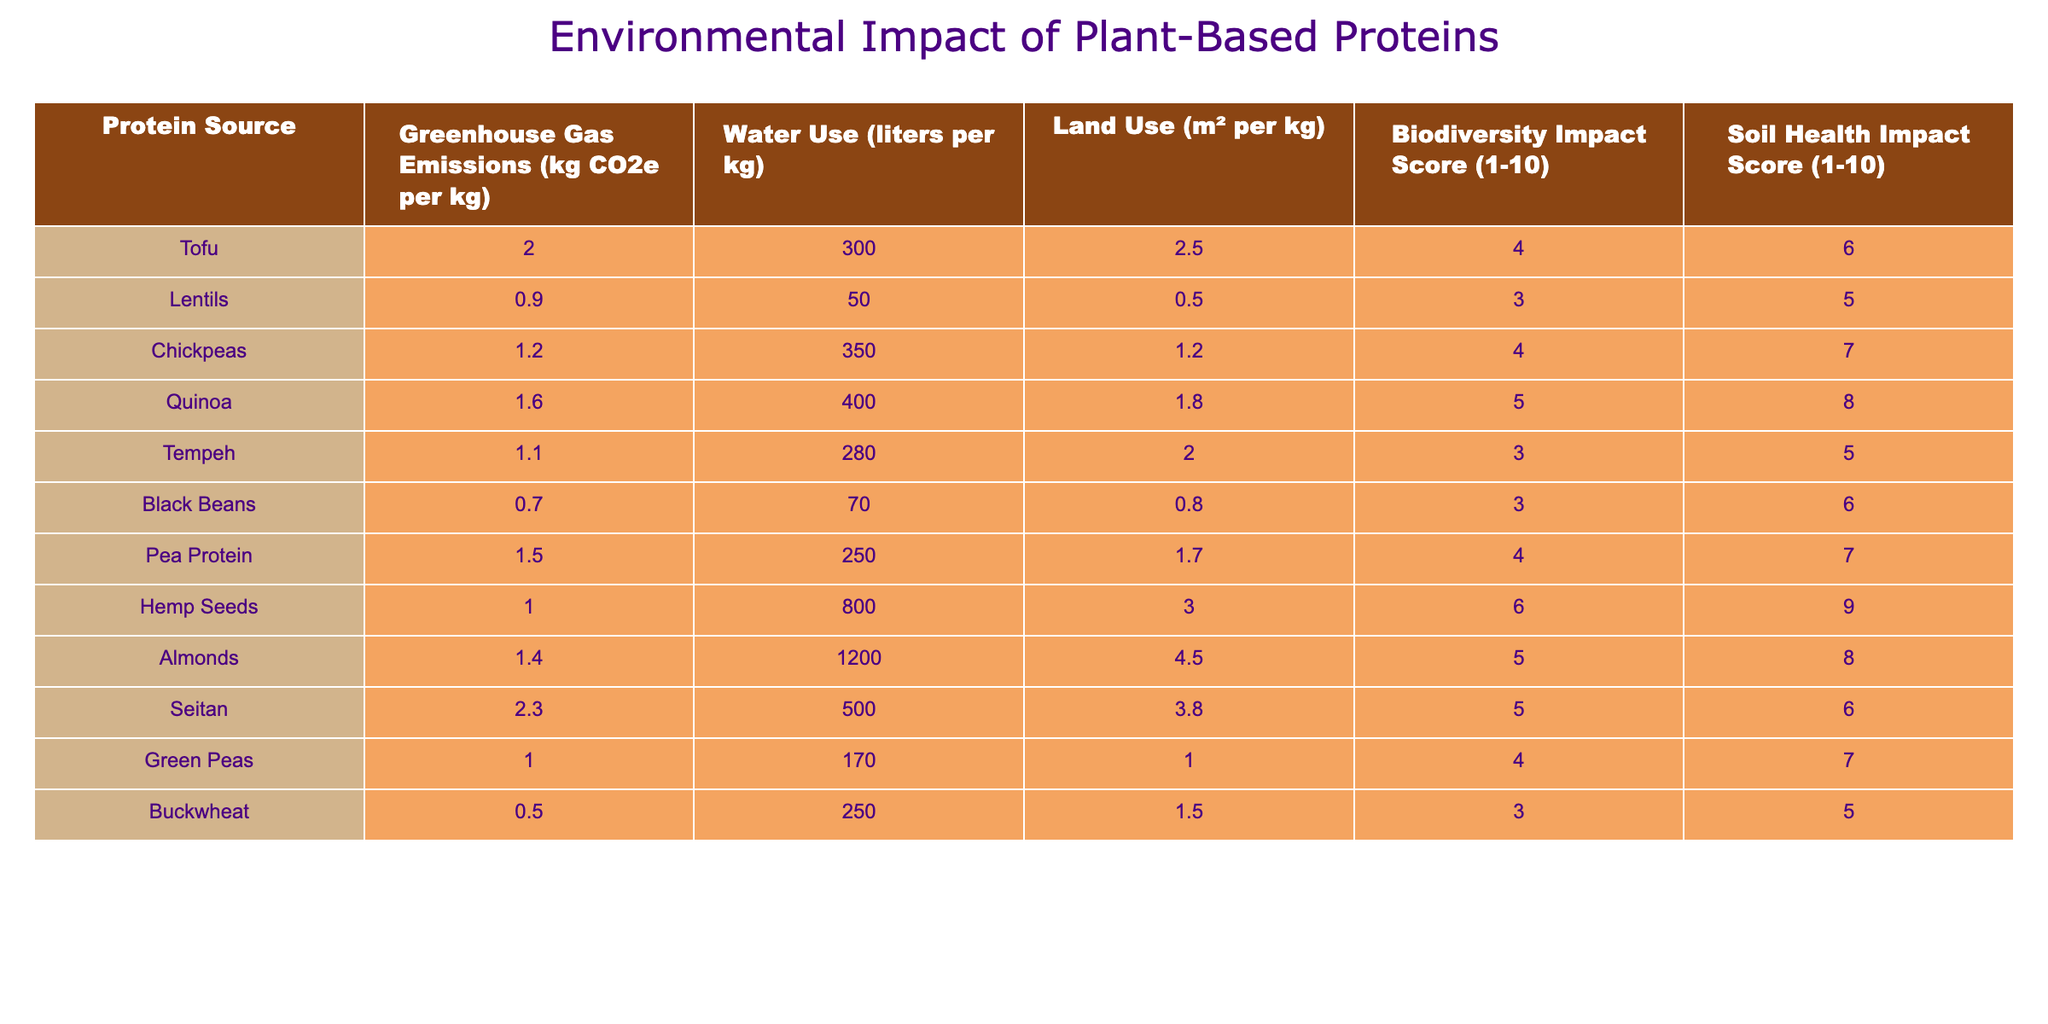What protein source has the highest greenhouse gas emissions? Looking at the greenhouse gas emissions column, we see that Seitan has the highest value at 2.3 kg CO2e per kg.
Answer: Seitan What is the water use for Buckwheat? Referring to the water use column for Buckwheat, the value is 250 liters per kg.
Answer: 250 liters Which protein source has the lowest land use? Checking the land use column, Black Beans have the lowest value at 0.8 m² per kg.
Answer: Black Beans What is the average soil health impact score of all the protein sources? To find the average, we sum all the soil health impact scores (6 + 5 + 7 + 8 + 5 + 6 + 7 + 9 + 8 + 6 + 7 + 5) = 6.5, then divide by the number of sources (12), resulting in an average of approximately 6.5.
Answer: 6.5 Is the biodiversity impact score of Tofu greater than 5? Tofu has a biodiversity impact score of 4, which is not greater than 5.
Answer: No How much more water do Almonds use compared to Black Beans? Almonds use 1200 liters per kg and Black Beans use 70 liters per kg. Thus, the difference is 1200 - 70 = 1130 liters.
Answer: 1130 liters Which protein sources have a biodiversity impact score of 5 or higher? The sources with a score of 5 or higher are Quinoa, Hemp Seeds, Almonds, Seitan, and Green Peas.
Answer: Quinoa, Hemp Seeds, Almonds, Seitan, Green Peas What is the total land use of Chickpeas and Pea Protein combined? The land use for Chickpeas is 1.2 m² per kg and for Pea Protein it's 1.7 m² per kg; their total is 1.2 + 1.7 = 2.9 m² per kg.
Answer: 2.9 m² Which protein has both the lowest greenhouse gas emissions and the lowest water use? The protein sources with the lowest greenhouse gas emissions are Black Beans (0.7 kg CO2e per kg) and they also have a low water use of 70 liters per kg.
Answer: Black Beans What is the highest water use protein source and what is its value? The highest water use value in the table is for Almonds, at 1200 liters per kg.
Answer: Almonds, 1200 liters 